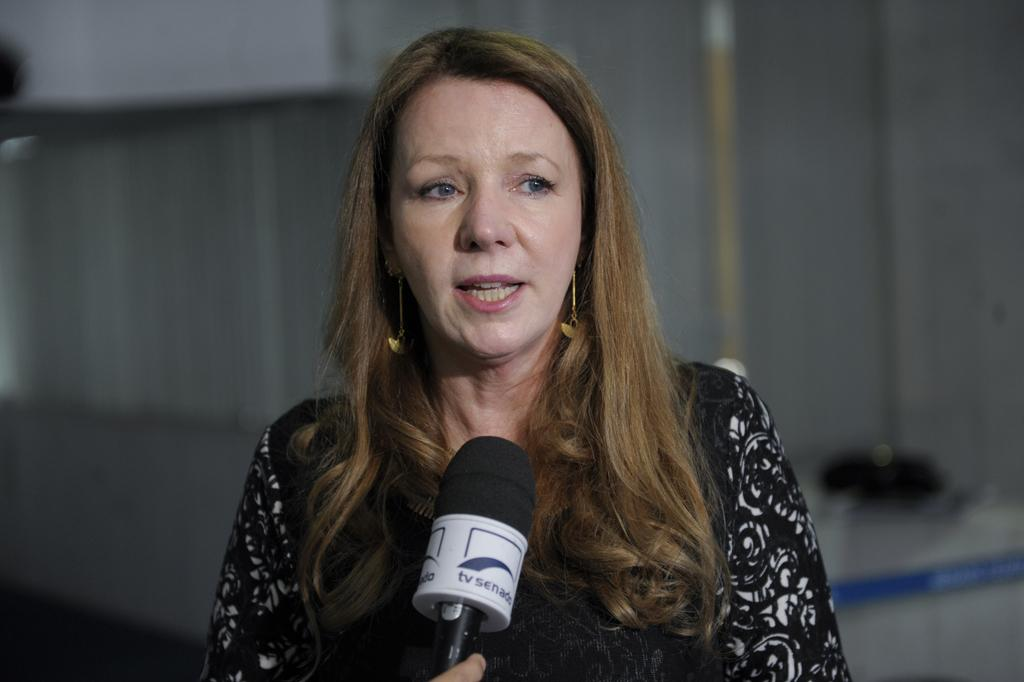What is the main subject of the image? There is a person in the image. What is the person doing in the image? The person is standing in front of a mic. What type of vase can be seen on the island in the image? There is no vase or island present in the image; it features a person standing in front of a mic. Can you describe the woman in the image? There is no woman mentioned in the provided facts, only a person. 